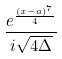<formula> <loc_0><loc_0><loc_500><loc_500>\frac { e ^ { \frac { ( x - a ) ^ { 7 } } { 4 } } } { i \sqrt { 4 \Delta } }</formula> 